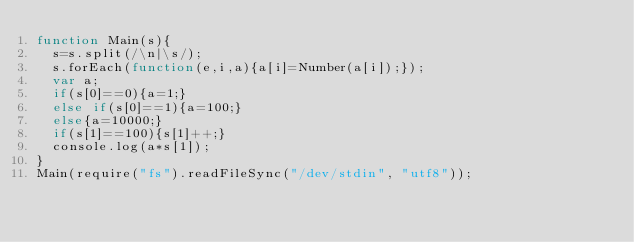Convert code to text. <code><loc_0><loc_0><loc_500><loc_500><_JavaScript_>function Main(s){
	s=s.split(/\n|\s/);
	s.forEach(function(e,i,a){a[i]=Number(a[i]);});
	var a;
	if(s[0]==0){a=1;}
	else if(s[0]==1){a=100;}
	else{a=10000;}
	if(s[1]==100){s[1]++;}
	console.log(a*s[1]);
}
Main(require("fs").readFileSync("/dev/stdin", "utf8"));</code> 